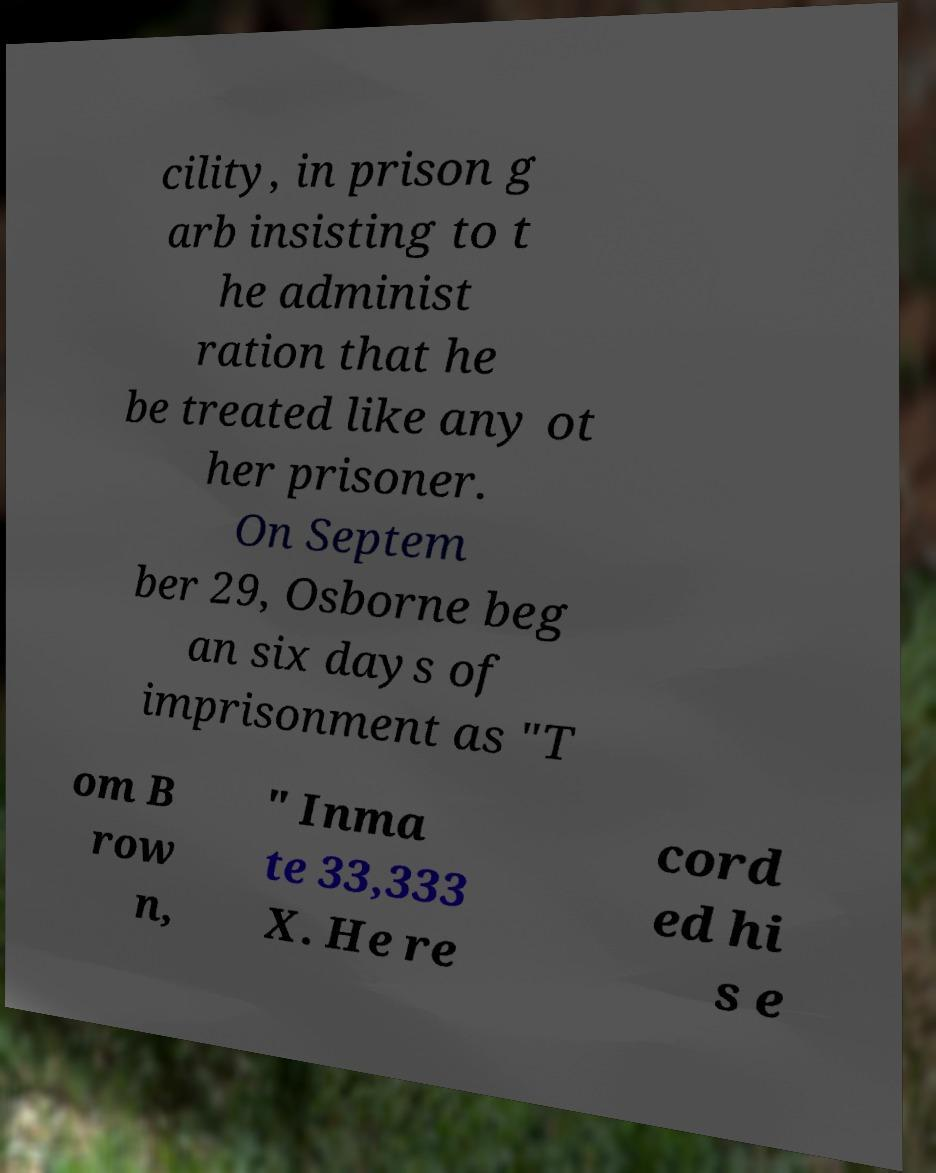Please read and relay the text visible in this image. What does it say? cility, in prison g arb insisting to t he administ ration that he be treated like any ot her prisoner. On Septem ber 29, Osborne beg an six days of imprisonment as "T om B row n, " Inma te 33,333 X. He re cord ed hi s e 